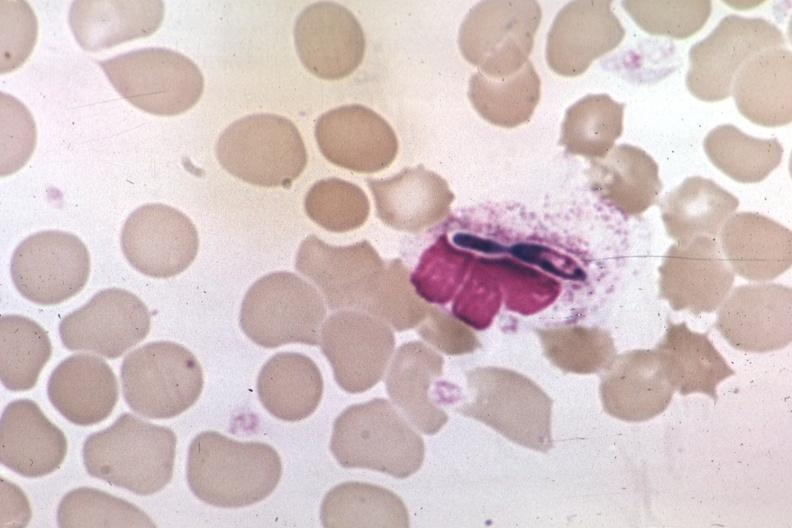s fibroma present?
Answer the question using a single word or phrase. No 